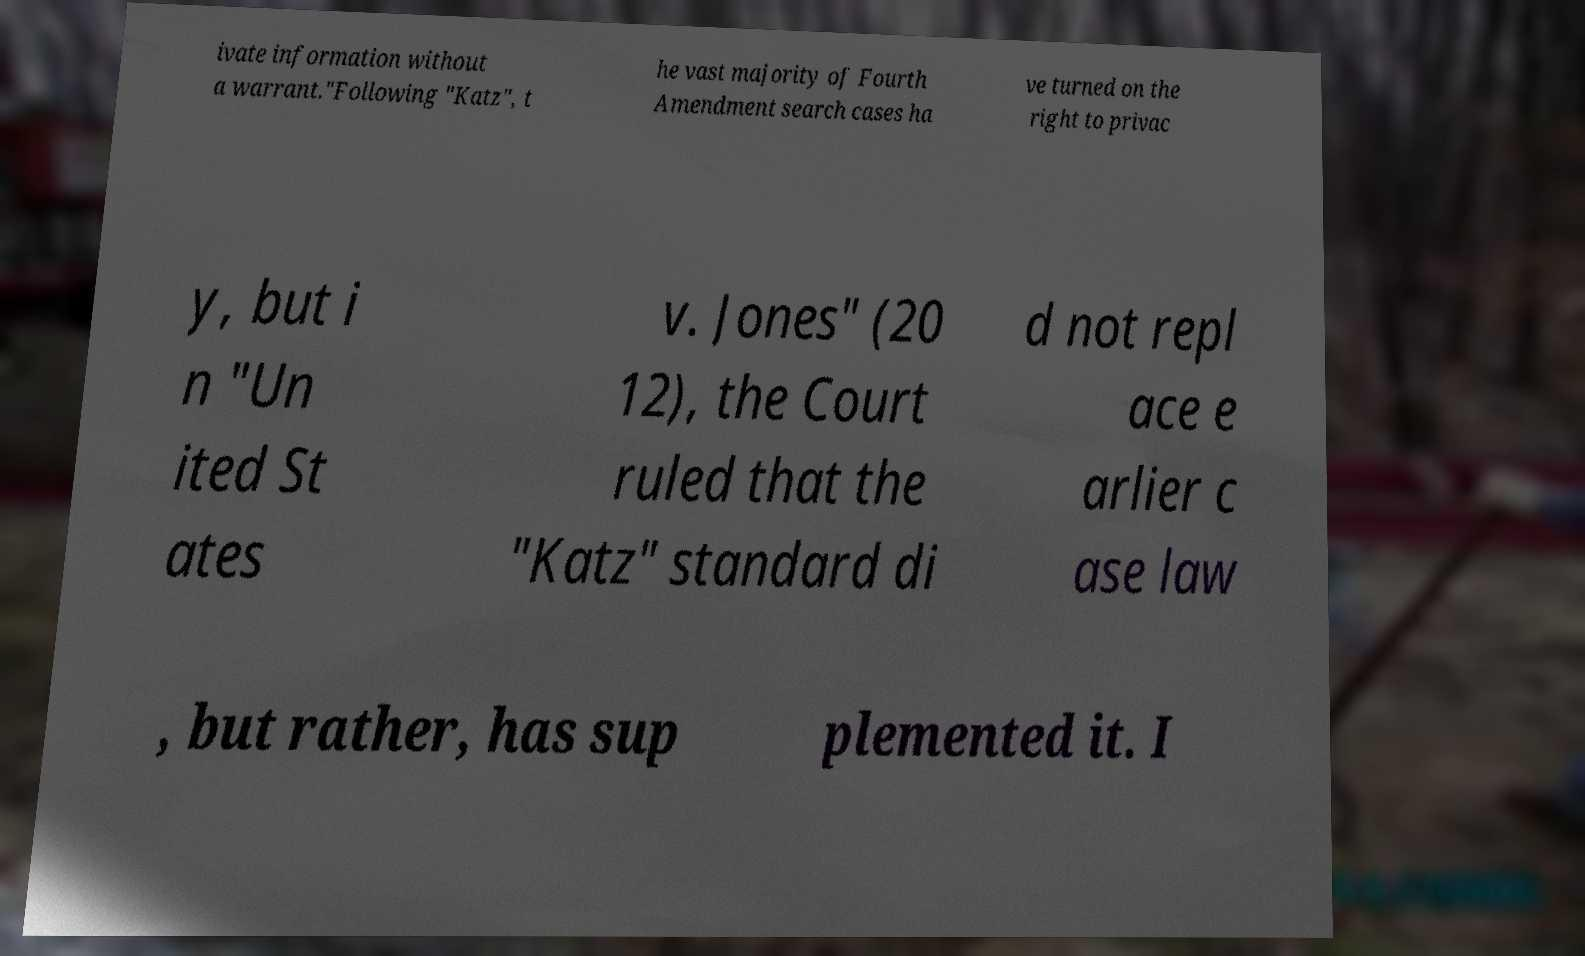There's text embedded in this image that I need extracted. Can you transcribe it verbatim? ivate information without a warrant."Following "Katz", t he vast majority of Fourth Amendment search cases ha ve turned on the right to privac y, but i n "Un ited St ates v. Jones" (20 12), the Court ruled that the "Katz" standard di d not repl ace e arlier c ase law , but rather, has sup plemented it. I 